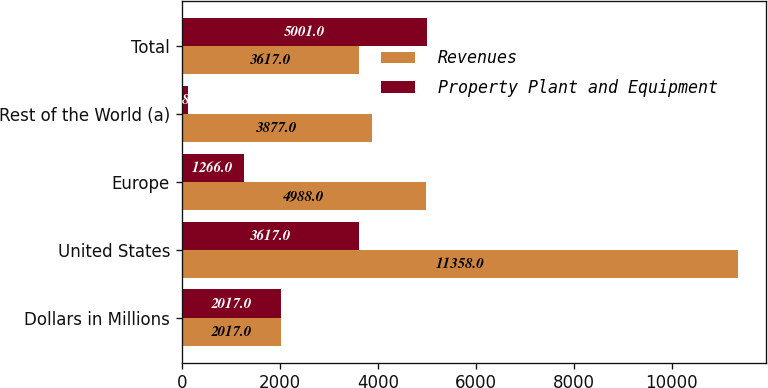Convert chart to OTSL. <chart><loc_0><loc_0><loc_500><loc_500><stacked_bar_chart><ecel><fcel>Dollars in Millions<fcel>United States<fcel>Europe<fcel>Rest of the World (a)<fcel>Total<nl><fcel>Revenues<fcel>2017<fcel>11358<fcel>4988<fcel>3877<fcel>3617<nl><fcel>Property Plant and Equipment<fcel>2017<fcel>3617<fcel>1266<fcel>118<fcel>5001<nl></chart> 